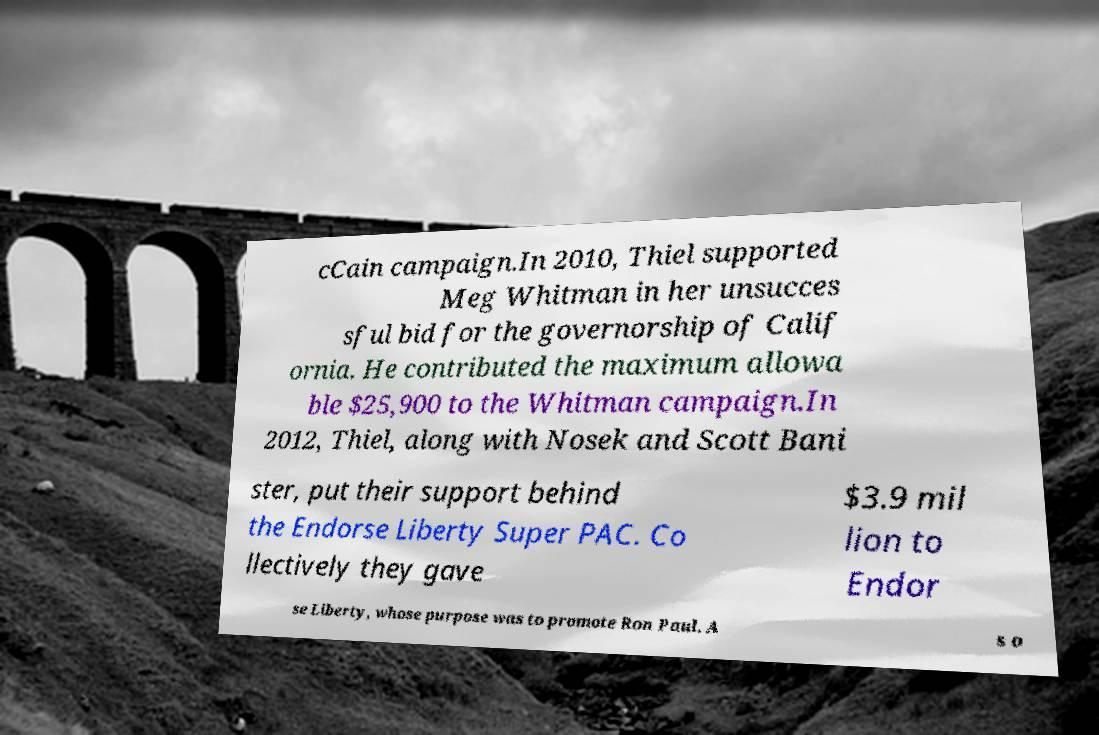Please read and relay the text visible in this image. What does it say? cCain campaign.In 2010, Thiel supported Meg Whitman in her unsucces sful bid for the governorship of Calif ornia. He contributed the maximum allowa ble $25,900 to the Whitman campaign.In 2012, Thiel, along with Nosek and Scott Bani ster, put their support behind the Endorse Liberty Super PAC. Co llectively they gave $3.9 mil lion to Endor se Liberty, whose purpose was to promote Ron Paul. A s o 